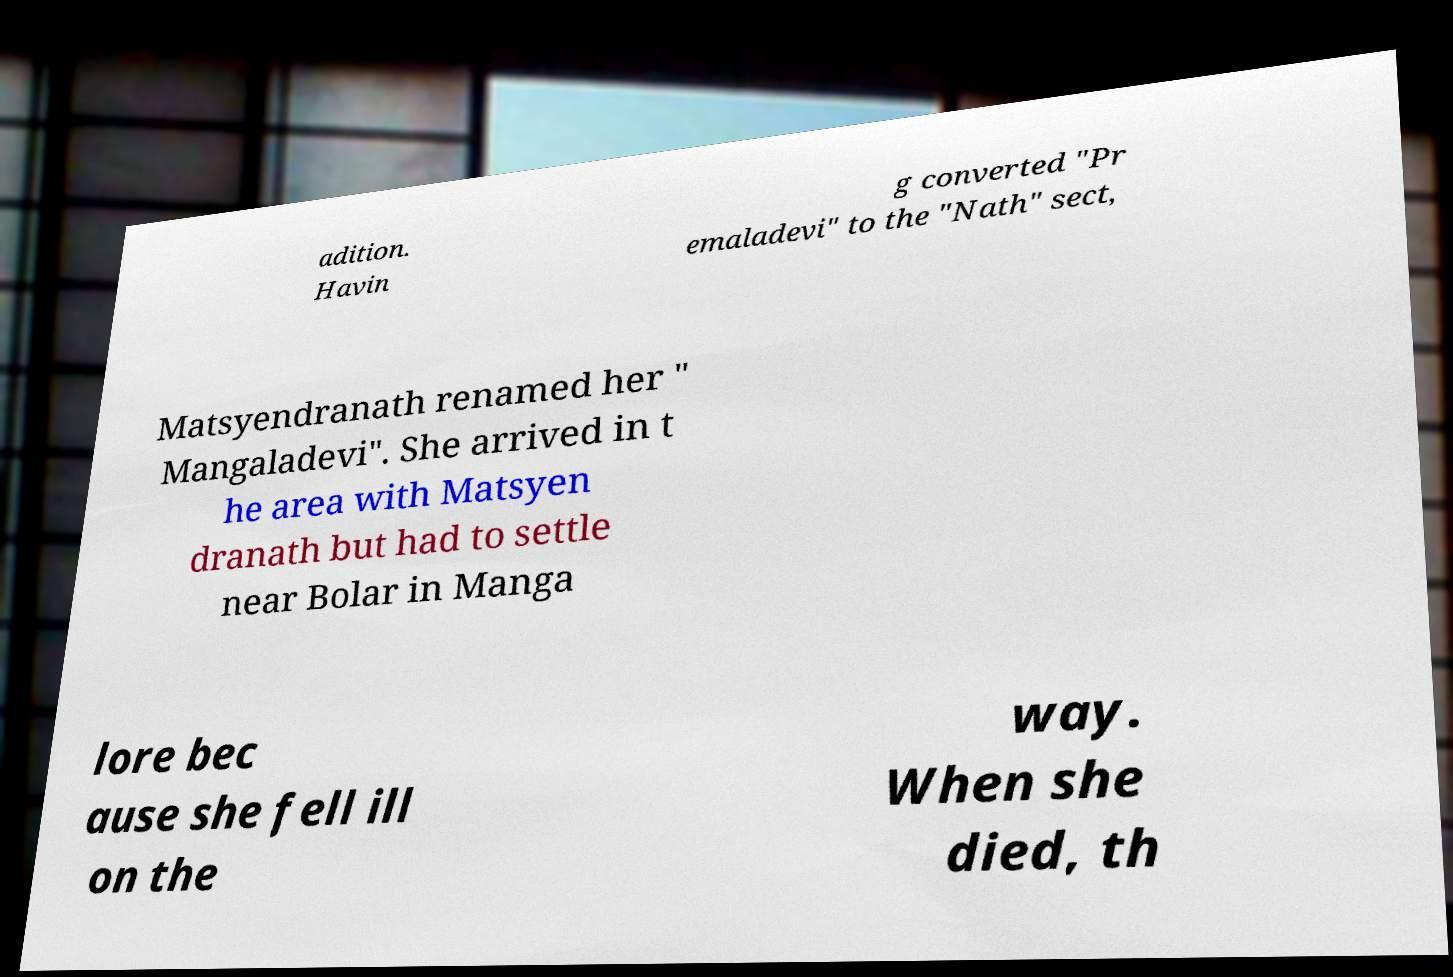I need the written content from this picture converted into text. Can you do that? adition. Havin g converted "Pr emaladevi" to the "Nath" sect, Matsyendranath renamed her " Mangaladevi". She arrived in t he area with Matsyen dranath but had to settle near Bolar in Manga lore bec ause she fell ill on the way. When she died, th 